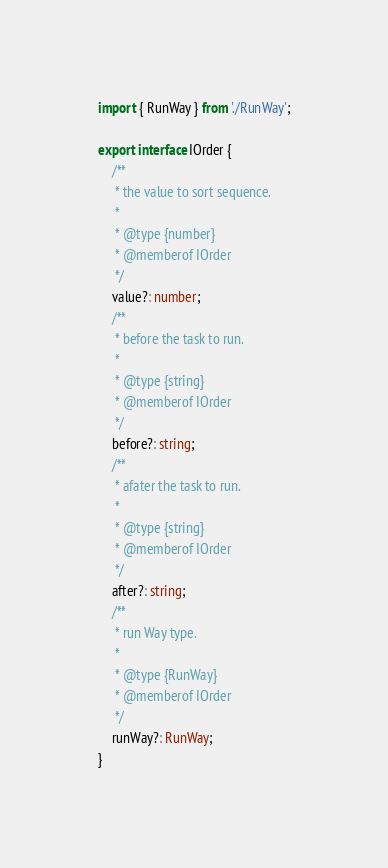<code> <loc_0><loc_0><loc_500><loc_500><_TypeScript_>
import { RunWay } from './RunWay';

export interface IOrder {
    /**
     * the value to sort sequence.
     *
     * @type {number}
     * @memberof IOrder
     */
    value?: number;
    /**
     * before the task to run.
     *
     * @type {string}
     * @memberof IOrder
     */
    before?: string;
    /**
     * afater the task to run.
     *
     * @type {string}
     * @memberof IOrder
     */
    after?: string;
    /**
     * run Way type.
     *
     * @type {RunWay}
     * @memberof IOrder
     */
    runWay?: RunWay;
}
</code> 